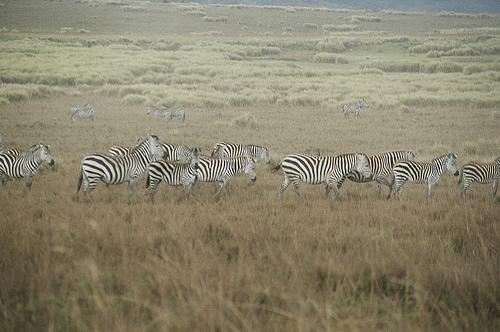Question: who is there?
Choices:
A. A man.
B. A woman.
C. A child.
D. No one.
Answer with the letter. Answer: D Question: what animals are there?
Choices:
A. Horses.
B. Zebras.
C. Elephants.
D. Giraffes.
Answer with the letter. Answer: B Question: what type of scene is this?
Choices:
A. Indoor.
B. A ball game.
C. A beach.
D. Outdoor.
Answer with the letter. Answer: D Question: what color are the zebras?
Choices:
A. White and black.
B. Black and white.
C. Black and brown.
D. Gold and brown.
Answer with the letter. Answer: B 